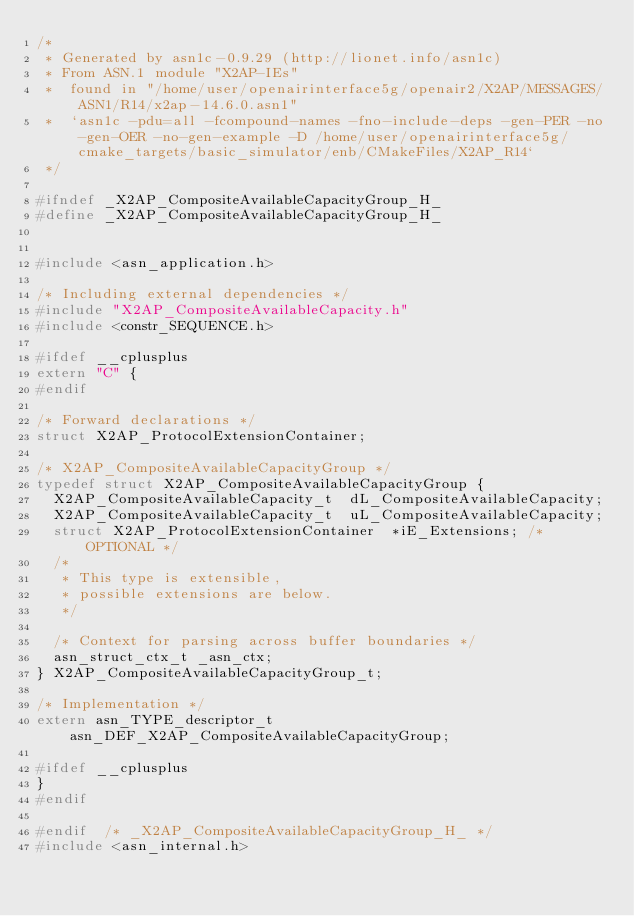Convert code to text. <code><loc_0><loc_0><loc_500><loc_500><_C_>/*
 * Generated by asn1c-0.9.29 (http://lionet.info/asn1c)
 * From ASN.1 module "X2AP-IEs"
 * 	found in "/home/user/openairinterface5g/openair2/X2AP/MESSAGES/ASN1/R14/x2ap-14.6.0.asn1"
 * 	`asn1c -pdu=all -fcompound-names -fno-include-deps -gen-PER -no-gen-OER -no-gen-example -D /home/user/openairinterface5g/cmake_targets/basic_simulator/enb/CMakeFiles/X2AP_R14`
 */

#ifndef	_X2AP_CompositeAvailableCapacityGroup_H_
#define	_X2AP_CompositeAvailableCapacityGroup_H_


#include <asn_application.h>

/* Including external dependencies */
#include "X2AP_CompositeAvailableCapacity.h"
#include <constr_SEQUENCE.h>

#ifdef __cplusplus
extern "C" {
#endif

/* Forward declarations */
struct X2AP_ProtocolExtensionContainer;

/* X2AP_CompositeAvailableCapacityGroup */
typedef struct X2AP_CompositeAvailableCapacityGroup {
	X2AP_CompositeAvailableCapacity_t	 dL_CompositeAvailableCapacity;
	X2AP_CompositeAvailableCapacity_t	 uL_CompositeAvailableCapacity;
	struct X2AP_ProtocolExtensionContainer	*iE_Extensions;	/* OPTIONAL */
	/*
	 * This type is extensible,
	 * possible extensions are below.
	 */
	
	/* Context for parsing across buffer boundaries */
	asn_struct_ctx_t _asn_ctx;
} X2AP_CompositeAvailableCapacityGroup_t;

/* Implementation */
extern asn_TYPE_descriptor_t asn_DEF_X2AP_CompositeAvailableCapacityGroup;

#ifdef __cplusplus
}
#endif

#endif	/* _X2AP_CompositeAvailableCapacityGroup_H_ */
#include <asn_internal.h>
</code> 